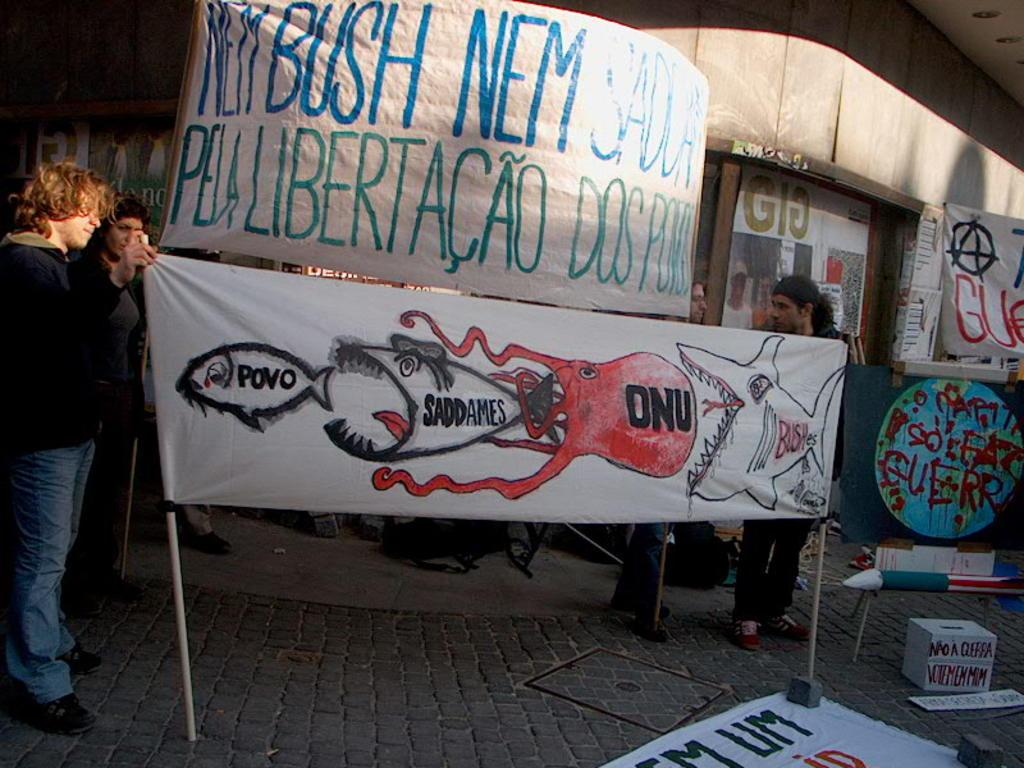What is the main focus of the image? The main focus of the image is the banners in the center. What are the people in the image doing? The people in the image are standing and holding banners. What can be seen in the background of the image? There is a building, a wall, and other objects visible in the background of the image. What is the price of the beetle in the image? There is no beetle present in the image, so it is not possible to determine its price. 